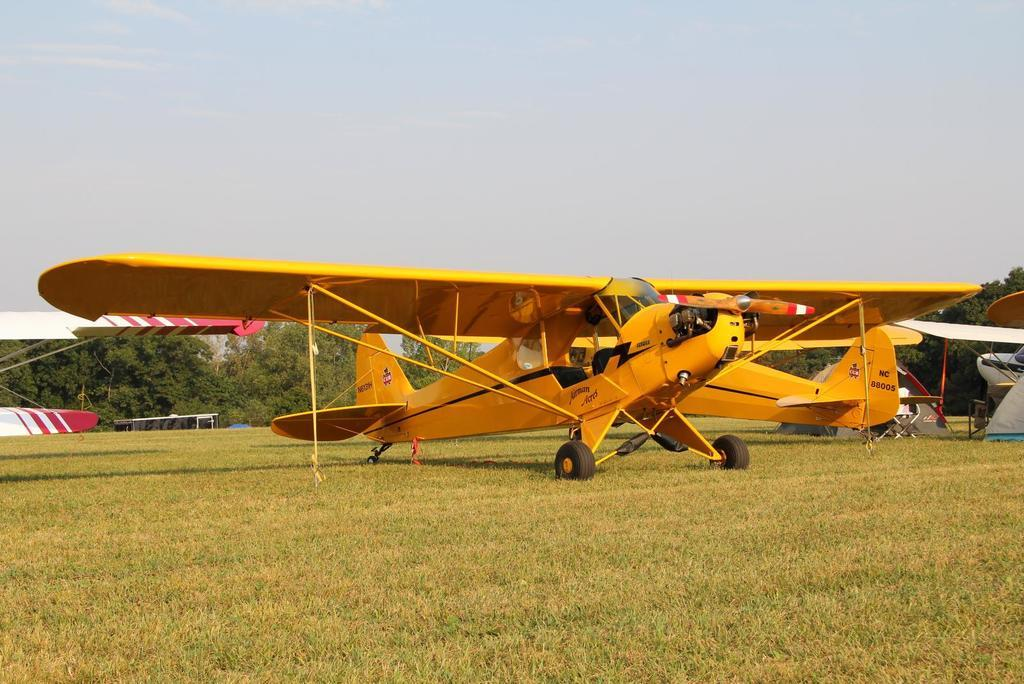What type of vehicles are in the image? There are two yellow color aircraft in the image. Where are the aircraft located? The aircraft are parked on the grass. Are there any other aircraft nearby? Yes, there are other aircraft in the vicinity. What can be seen in the background of the image? Trees and clouds are visible in the background of the image. What type of border is visible between the aircraft and the grass? There is no border visible between the aircraft and the grass; the aircraft are simply parked on the grass. 